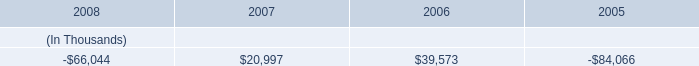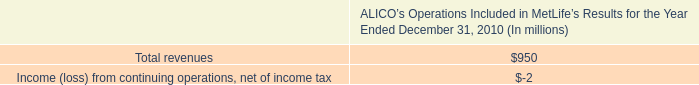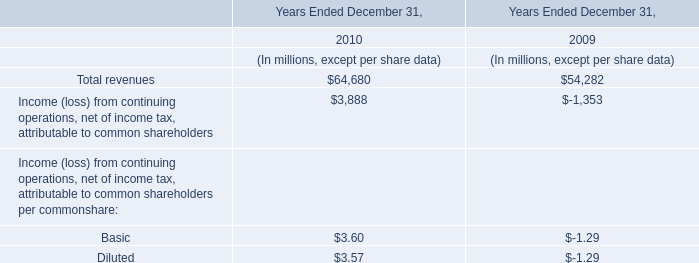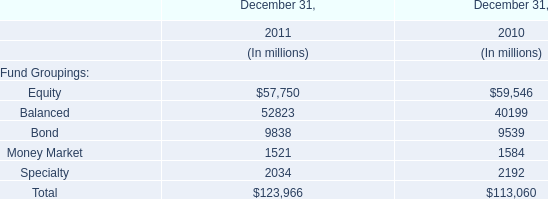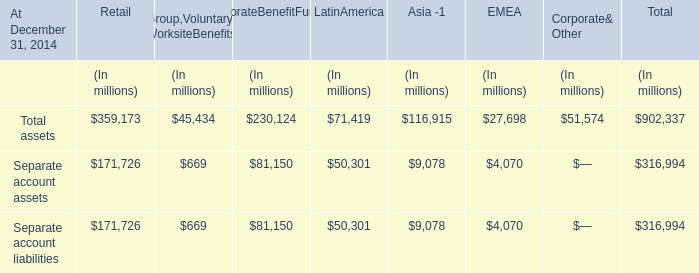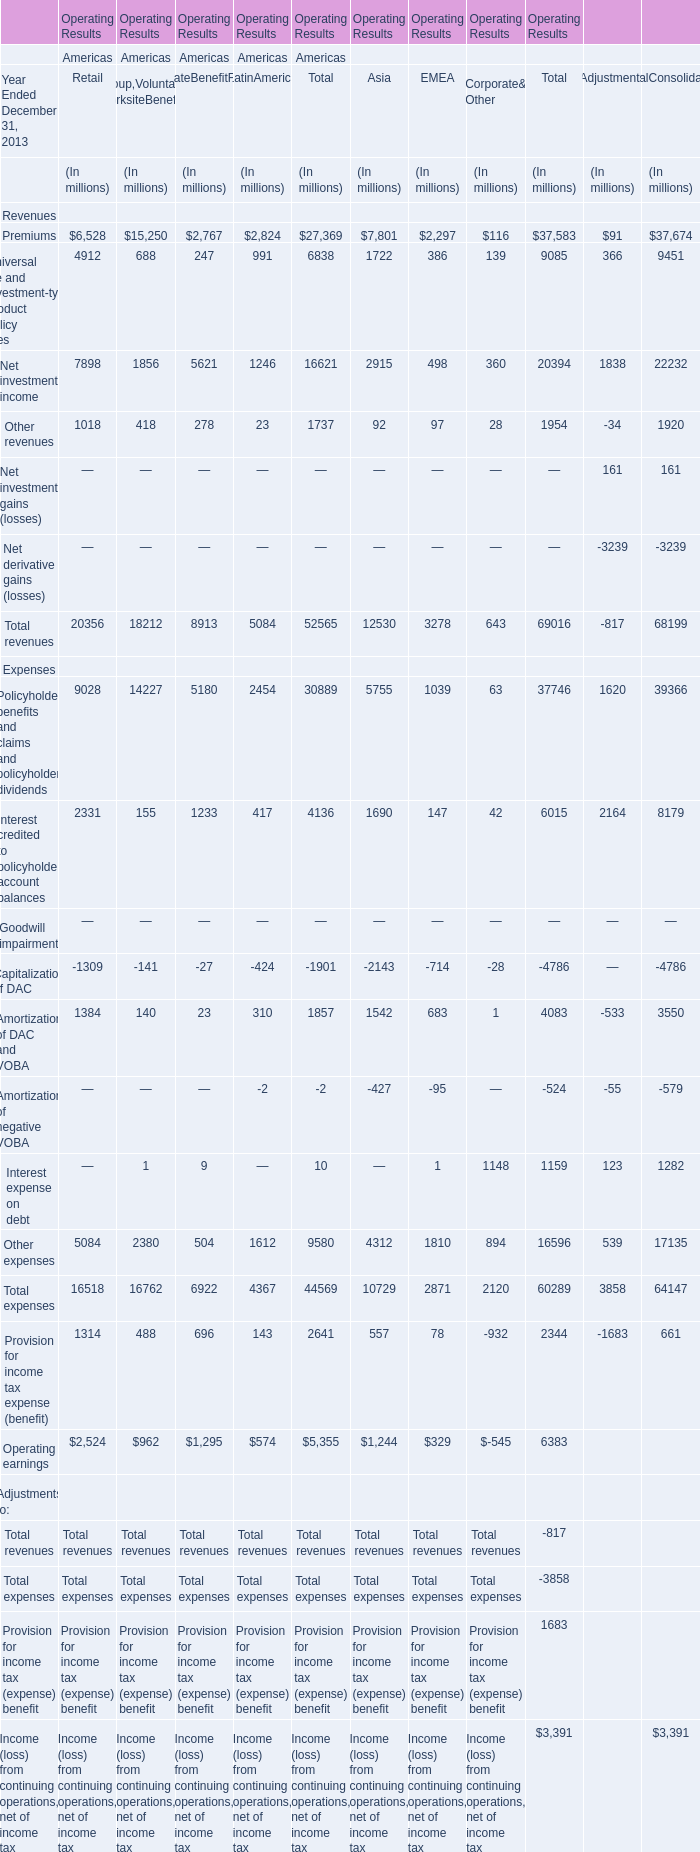What's the 1 % of total America's Total Premiums of Revenues in 2013? (in million) 
Computations: (0.01 * 27369)
Answer: 273.69. 